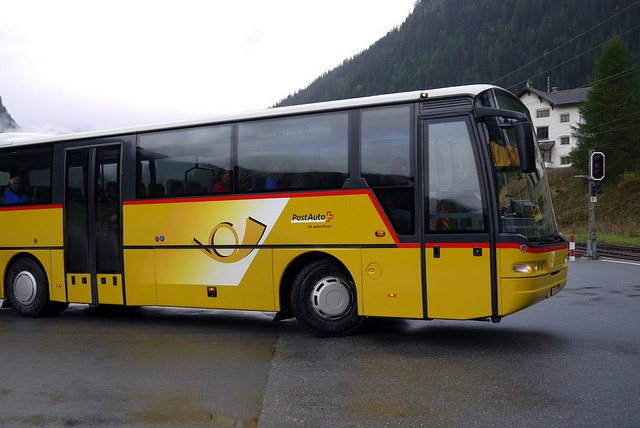Describe the objects in this image and their specific colors. I can see bus in white, black, olive, and gray tones and traffic light in white, black, gray, darkgray, and lightgray tones in this image. 